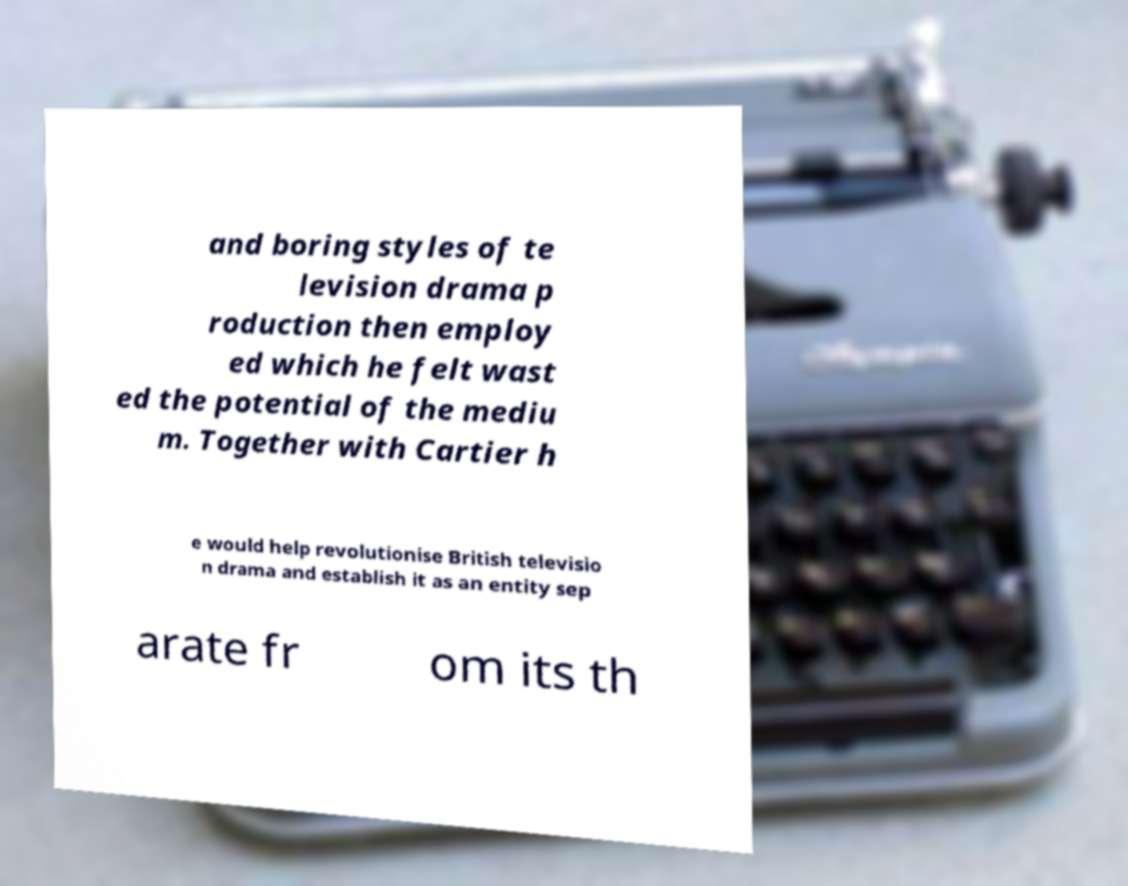Could you assist in decoding the text presented in this image and type it out clearly? and boring styles of te levision drama p roduction then employ ed which he felt wast ed the potential of the mediu m. Together with Cartier h e would help revolutionise British televisio n drama and establish it as an entity sep arate fr om its th 